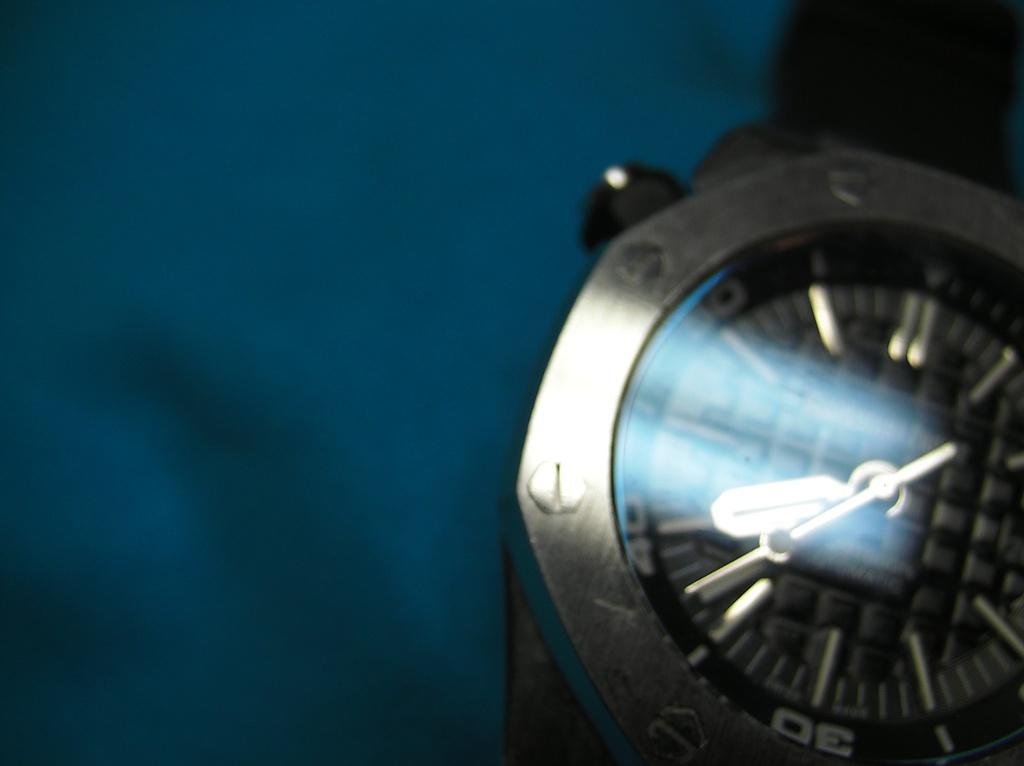<image>
Give a short and clear explanation of the subsequent image. The number 30 is visible on a blurry face of a watch. 